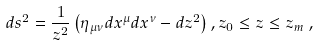<formula> <loc_0><loc_0><loc_500><loc_500>d s ^ { 2 } = \frac { 1 } { z ^ { 2 } } \left ( \eta _ { \mu \nu } d x ^ { \mu } d x ^ { \nu } - d z ^ { 2 } \right ) , z _ { 0 } \leq z \leq z _ { m } \, ,</formula> 